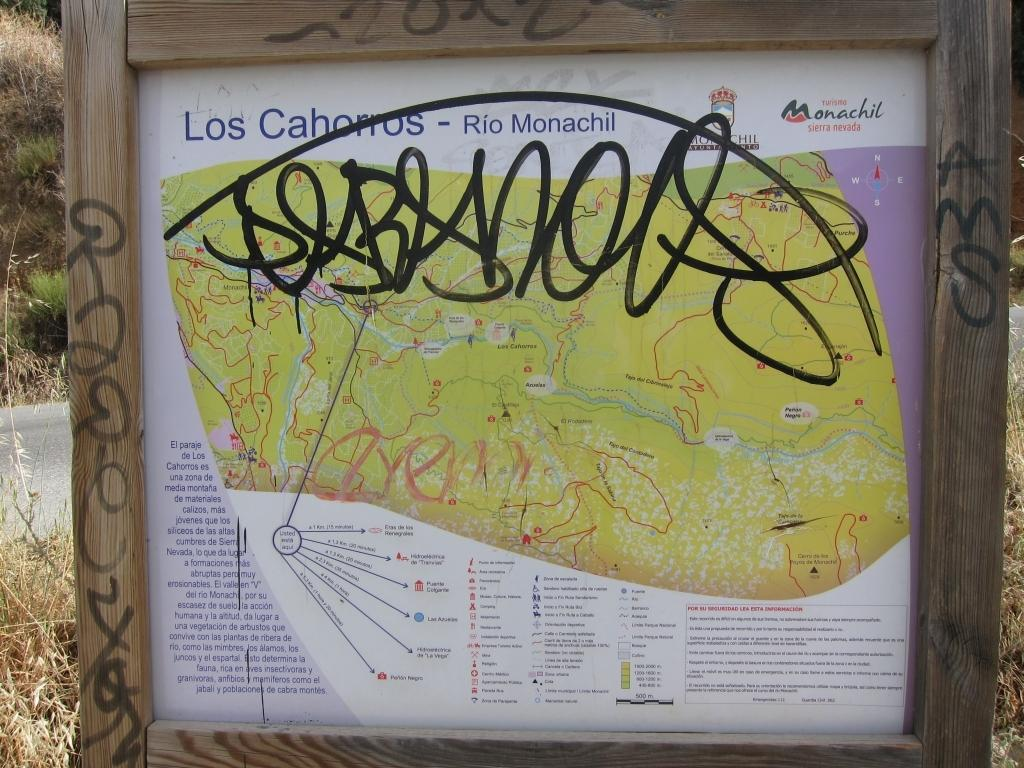Provide a one-sentence caption for the provided image. A vandalized, graffiti covered map pertains to the Sierra Nevada area. 